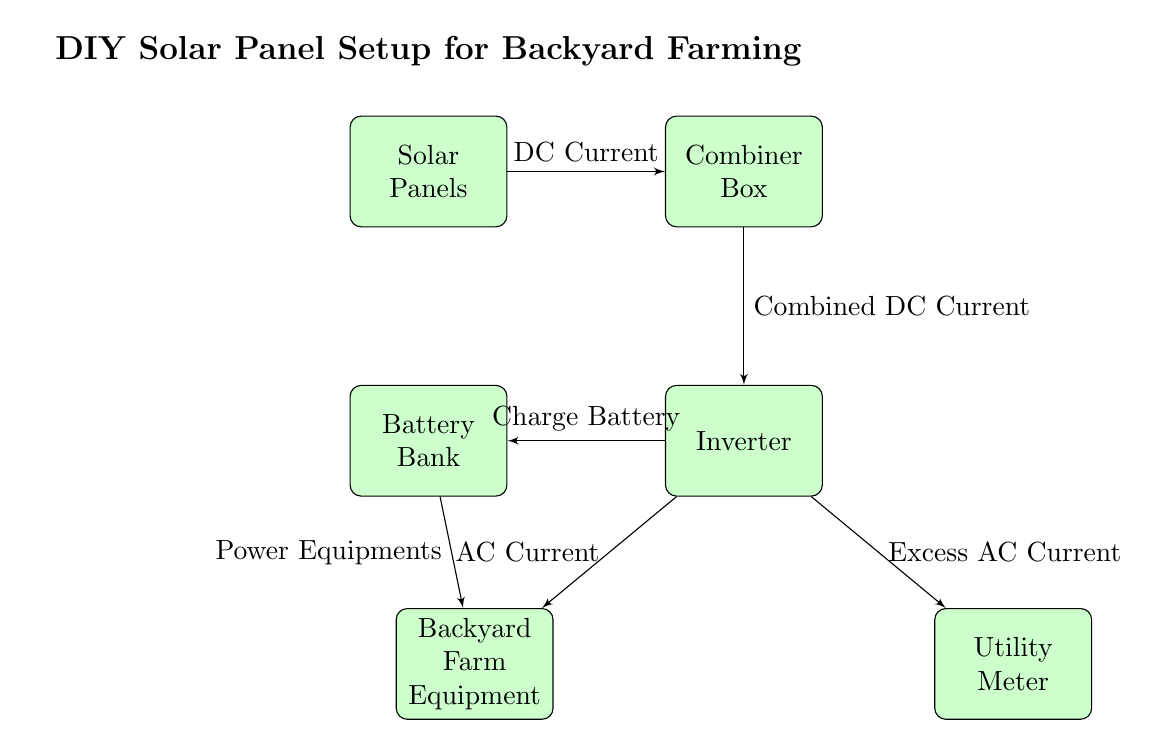What is the first component in the energy flow? The first component in the energy flow is the solar panels, which collect solar energy and convert it into DC current.
Answer: Solar Panels How many components are depicted in the diagram? Counting the nodes in the diagram, there are six main components: Solar Panels, Combiner Box, Inverter, Battery Bank, Backyard Farm Equipment, and Utility Meter.
Answer: Six What type of current is produced by the solar panels? The solar panels produce DC current, which is indicated as the type of energy flowing from the solar panels to the combiner box.
Answer: DC Current Which component is responsible for converting DC to AC current? The inverter is the component that converts DC current into AC current, which can then be used to power equipment or sent to the utility meter.
Answer: Inverter What does the inverter do with the excess AC current? The inverter sends the excess AC current to the utility meter, which is shown as a flow from the inverter to the meter in the diagram.
Answer: Utility Meter Which two components share energy from the inverter? The battery bank and the backyard farm equipment both receive energy from the inverter, with flows indicated to both components in the diagram.
Answer: Battery Bank and Backyard Farm Equipment What is the function of the combiner box in the setup? The combiner box functions as a central point that combines the output from the solar panels before sending the combined DC current to the inverter.
Answer: Combine DC Current How does the battery bank receive its charge? The battery bank charges by receiving DC current from the inverter, which is designated as the flow indicating how the battery is powered.
Answer: Charge Battery What type of current does the backyard farm equipment use? The backyard farm equipment uses AC current, as indicated by the flow from the inverter to the farm equipment in the diagram.
Answer: AC Current 